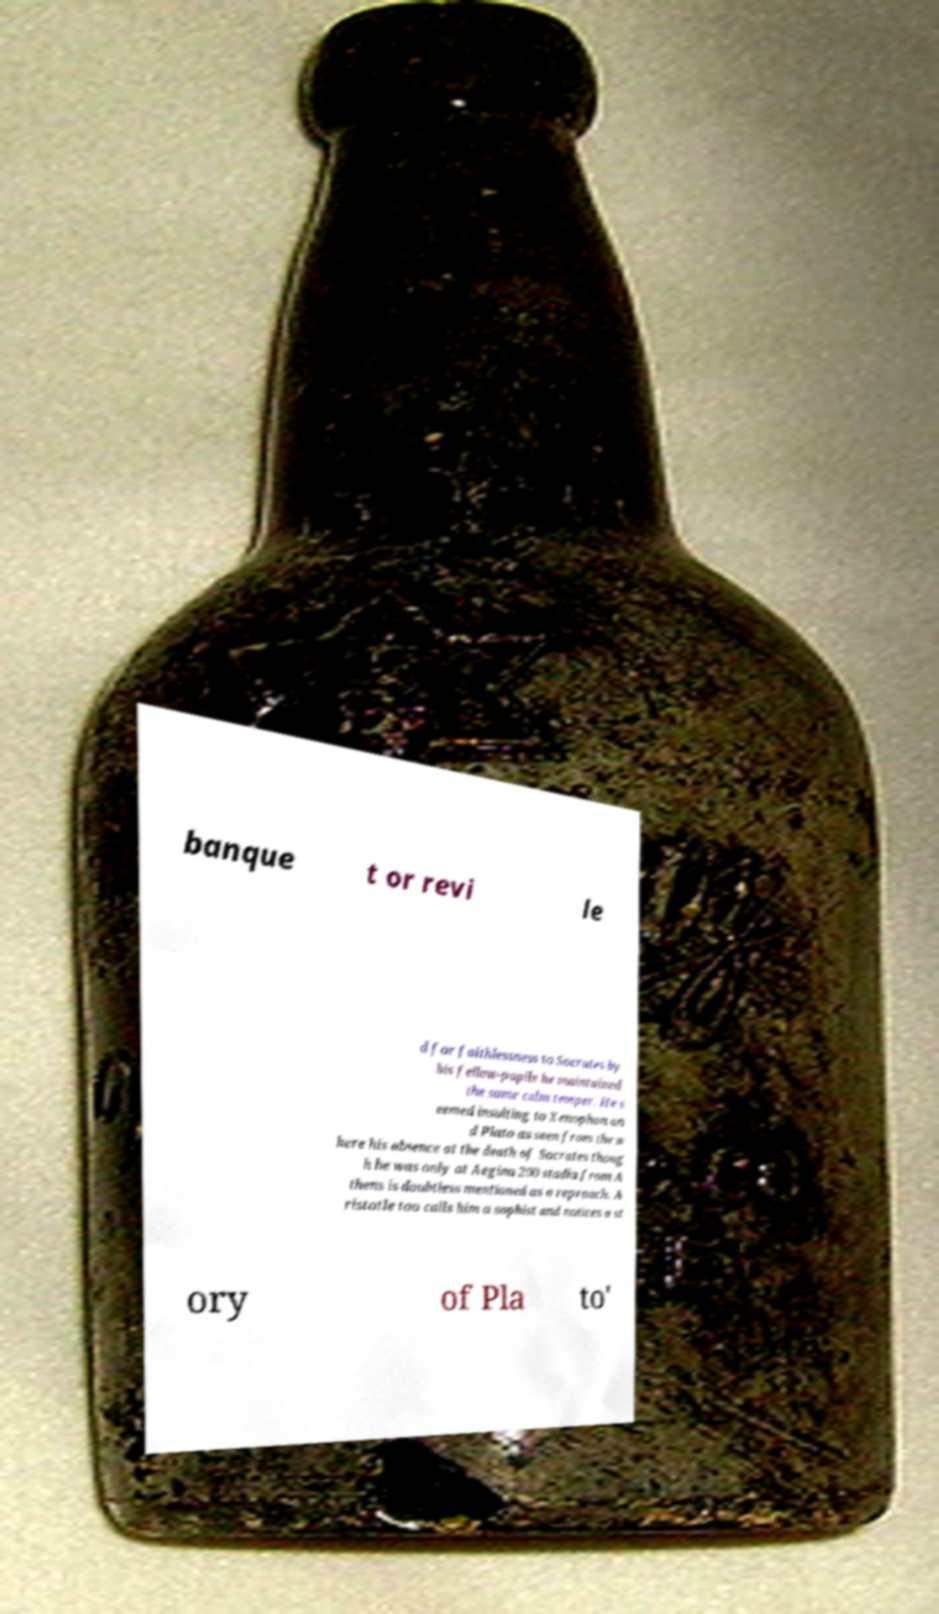Please read and relay the text visible in this image. What does it say? banque t or revi le d for faithlessness to Socrates by his fellow-pupils he maintained the same calm temper. He s eemed insulting to Xenophon an d Plato as seen from the w here his absence at the death of Socrates thoug h he was only at Aegina 200 stadia from A thens is doubtless mentioned as a reproach. A ristotle too calls him a sophist and notices a st ory of Pla to' 